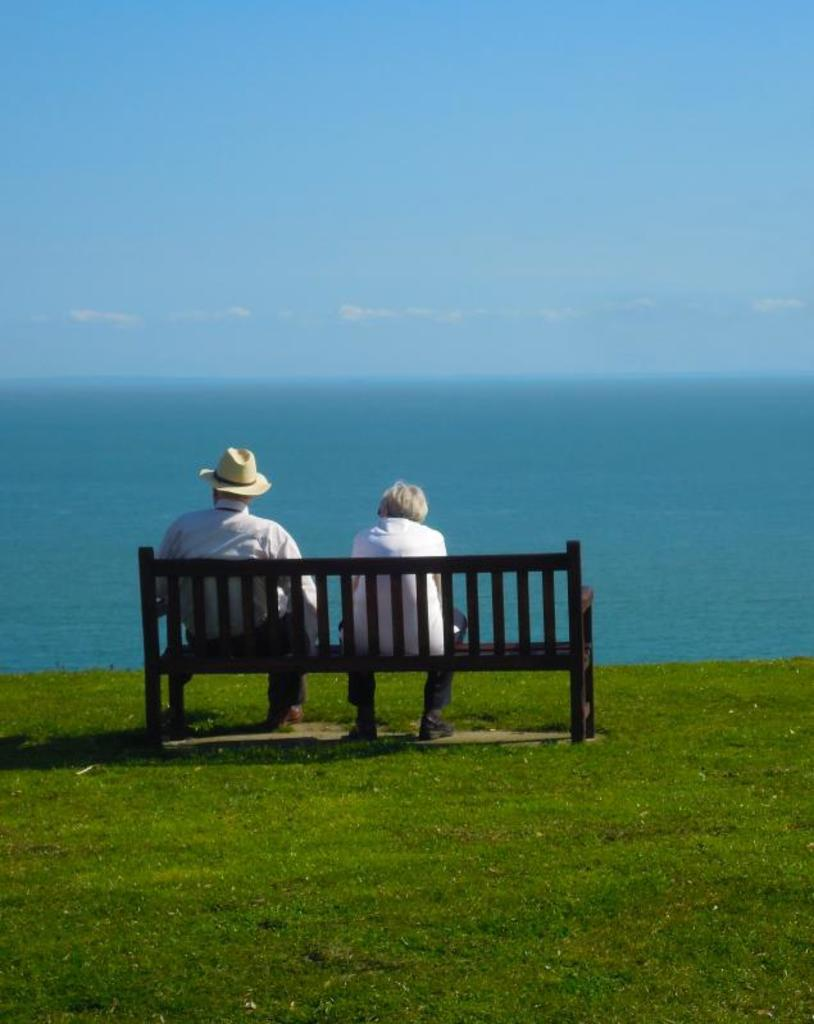Who are the people in the image? There is a man and a woman in the image. What are the man and woman doing in the image? Both the man and woman are sitting on a chair. What can be seen in the background of the image? There is sky and water visible in the background of the image. What type of breakfast is the man eating in the image? There is no breakfast visible in the image, as the man and woman are sitting on a chair without any food present. 